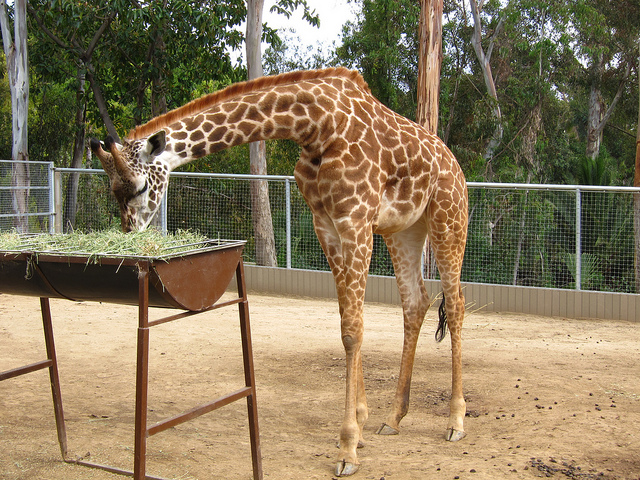What can you say about this giraffe's habitat? The giraffe appears to be in a zoo enclosure with a sandy ground and some vegetation. The enclosure is designed to be spacious and safe, providing shelter and mimicking the giraffe's natural savanna habitat to some extent. How do zoos benefit animals like giraffes? Zoos provide benefits like veterinary care, research opportunities for conservation, and educational programs for the public. They also offer protection for species that might be endangered or threatened in the wild. 